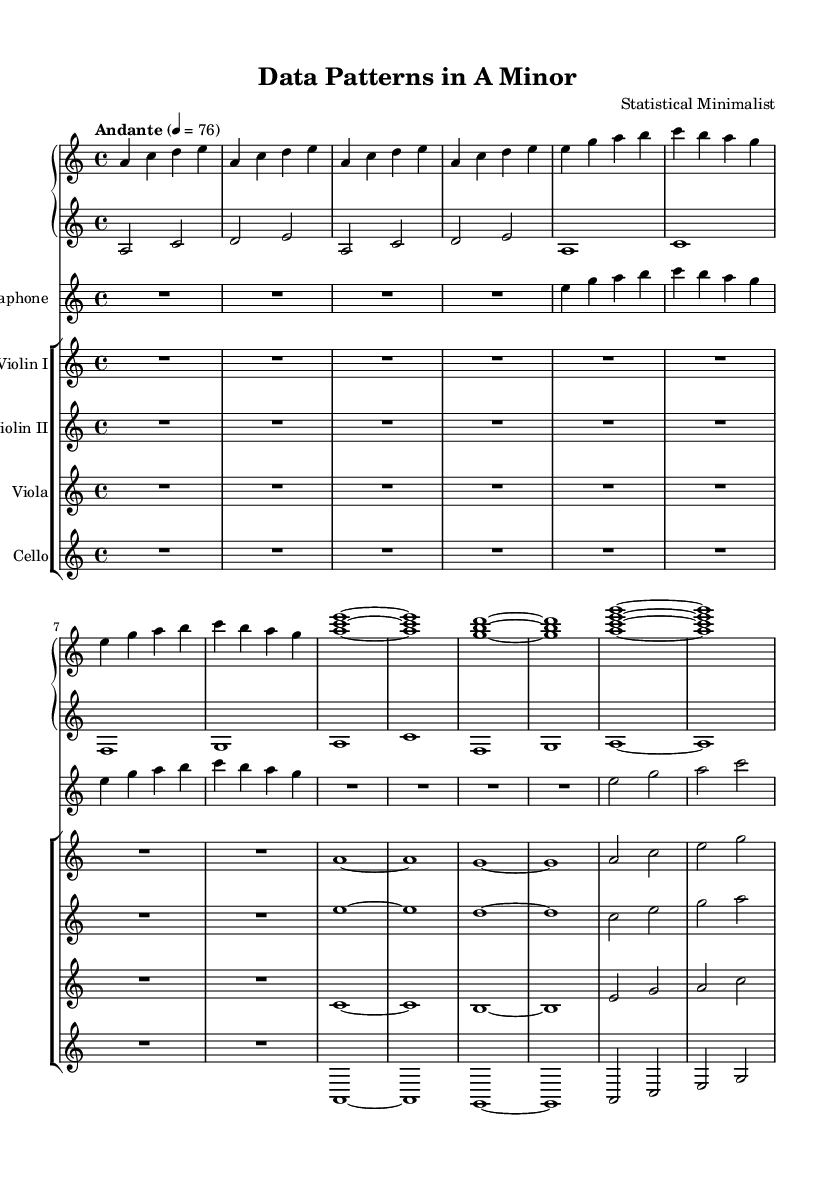What is the key signature of this music? The key signature is A minor, which has no sharps or flats.
Answer: A minor What is the time signature of this music? The time signature is 4/4, indicating four beats per measure.
Answer: 4/4 What is the tempo marking of this piece? The tempo marking indicates "Andante," suggesting a moderate walking pace, specifically noted as 76 beats per minute.
Answer: Andante How many sections are indicated in this composition? There are three distinct sections labeled as Introduction, Section A, Section B, and a Coda at the end. Each section presents different musical ideas.
Answer: Four What is the instrument used for the introduction? The introduction features a rest for all instruments, signified by "R1*4," which indicates a four-beat silence before the music starts.
Answer: Rest In Section B, what does the piano left hand primarily play? The piano left hand in Section B plays whole notes, specifically the notes A, C, F, and G, each sustaining for the full measure.
Answer: Whole notes How does the vibraphone contribute to the structure of this piece? The vibraphone primarily plays rests in the introduction and Section B, creating atmospheric spacing, then engages in melodic activity during Section A.
Answer: Rests 